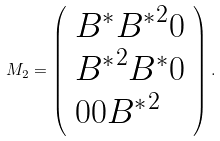Convert formula to latex. <formula><loc_0><loc_0><loc_500><loc_500>M _ { 2 } = \left ( \begin{array} { l l l } B ^ { * } { B ^ { * } } ^ { 2 } 0 \\ { B ^ { * } } ^ { 2 } B ^ { * } 0 \\ 0 0 { B ^ { * } } ^ { 2 } \\ \end{array} \right ) .</formula> 